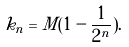<formula> <loc_0><loc_0><loc_500><loc_500>k _ { n } = M ( 1 - \frac { 1 } { 2 ^ { n } } ) .</formula> 